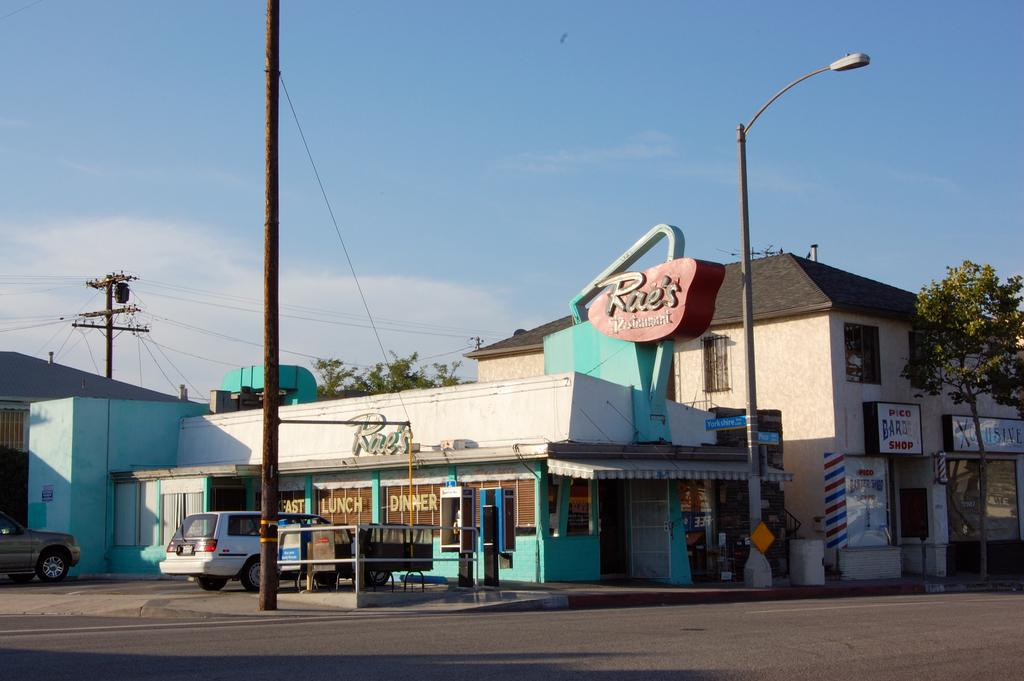What is located in the center of the image? There are buildings in the center of the image. What type of vehicles can be seen in the image? There are cars in the image. What structures are present to support electrical wiring? There are electric poles in the image. What type of lighting is present in the image? There is a street light in the image. What type of vegetation is present in the image? There are trees in the image. What is the main pathway visible in the image? There is a road at the bottom of the image. Where is the cactus located in the image? There is no cactus present in the image. What type of medical facility can be seen in the image? There is no hospital present in the image. What time of day is depicted in the image? The time of day cannot be determined from the image alone, as there is no specific information about lighting or shadows. 